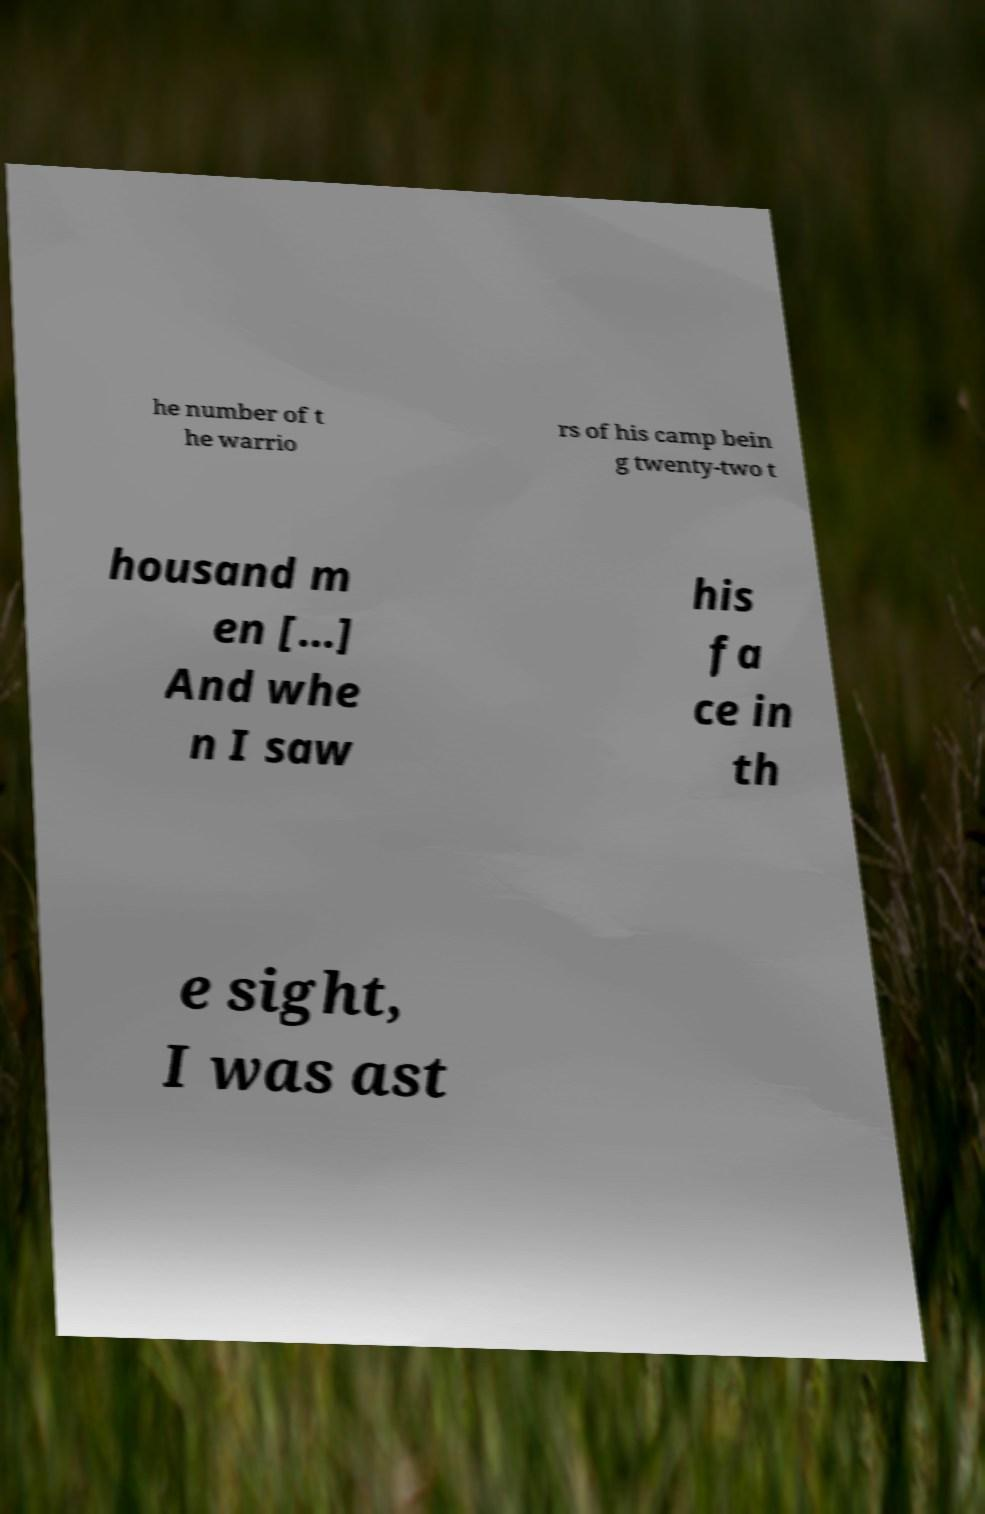Can you accurately transcribe the text from the provided image for me? he number of t he warrio rs of his camp bein g twenty-two t housand m en […] And whe n I saw his fa ce in th e sight, I was ast 